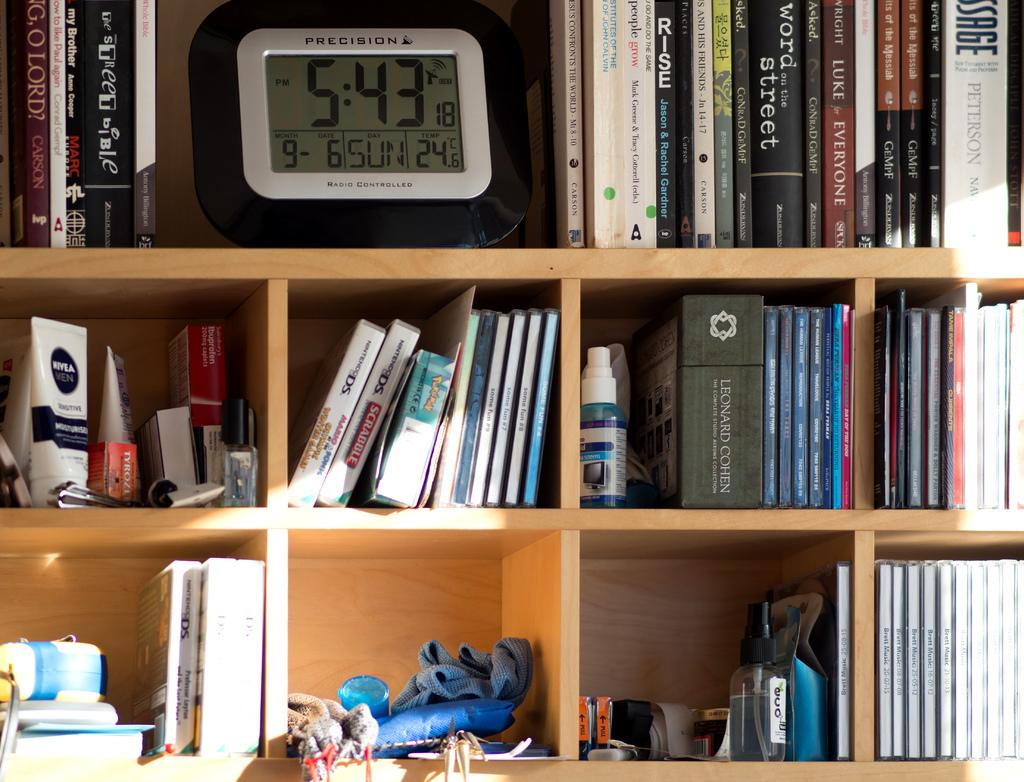Provide a one-sentence caption for the provided image. A radio controlled Precision clock on a shelf indicates the time. 